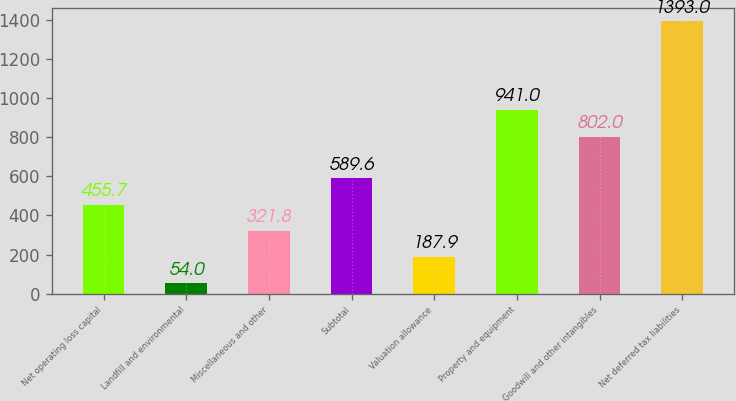<chart> <loc_0><loc_0><loc_500><loc_500><bar_chart><fcel>Net operating loss capital<fcel>Landfill and environmental<fcel>Miscellaneous and other<fcel>Subtotal<fcel>Valuation allowance<fcel>Property and equipment<fcel>Goodwill and other intangibles<fcel>Net deferred tax liabilities<nl><fcel>455.7<fcel>54<fcel>321.8<fcel>589.6<fcel>187.9<fcel>941<fcel>802<fcel>1393<nl></chart> 